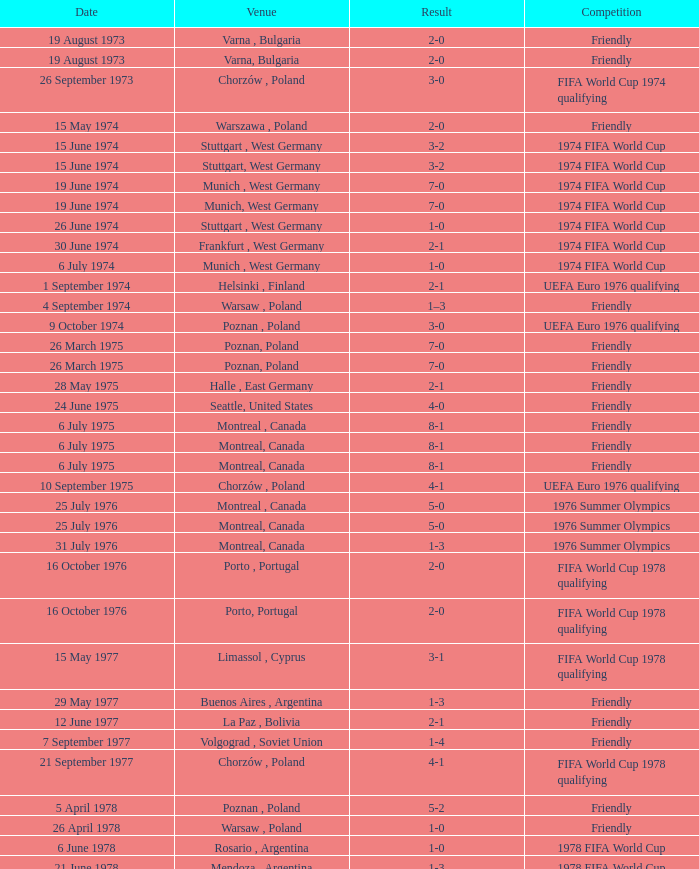What was the result of the game in Stuttgart, West Germany and a goal number of less than 9? 3-2, 3-2. 